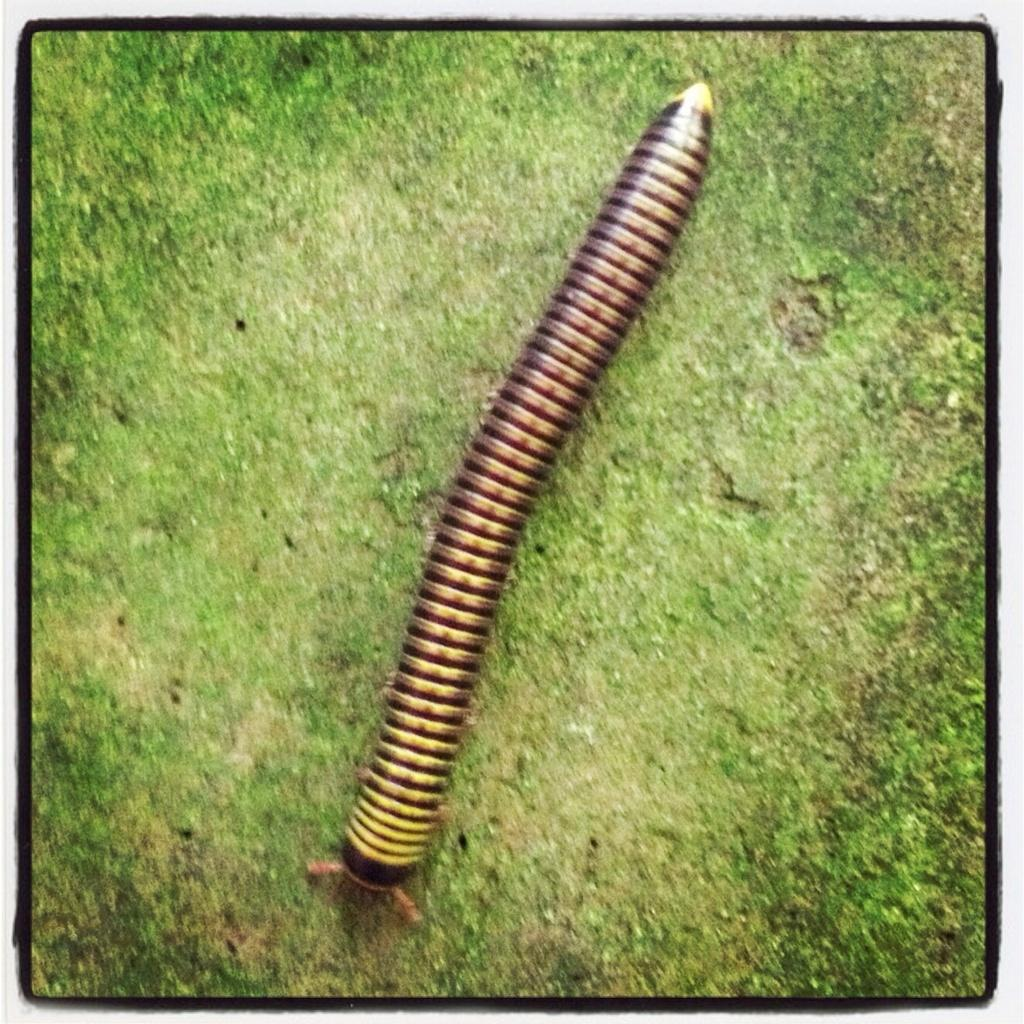What type of creature is present in the image? There is an insect in the image. Where is the insect located? The insect is on the ground. What type of lumber is the insect using to build its home in the image? There is no lumber present in the image, and the insect is not building a home. 